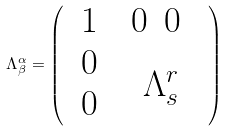<formula> <loc_0><loc_0><loc_500><loc_500>\Lambda ^ { \alpha } _ { \beta } = \left ( \begin{array} { c c } 1 & \begin{array} { c c } 0 & 0 \ \end{array} \\ \begin{array} { c } 0 \\ 0 \\ \end{array} & \Lambda ^ { r } _ { s } \end{array} \right )</formula> 